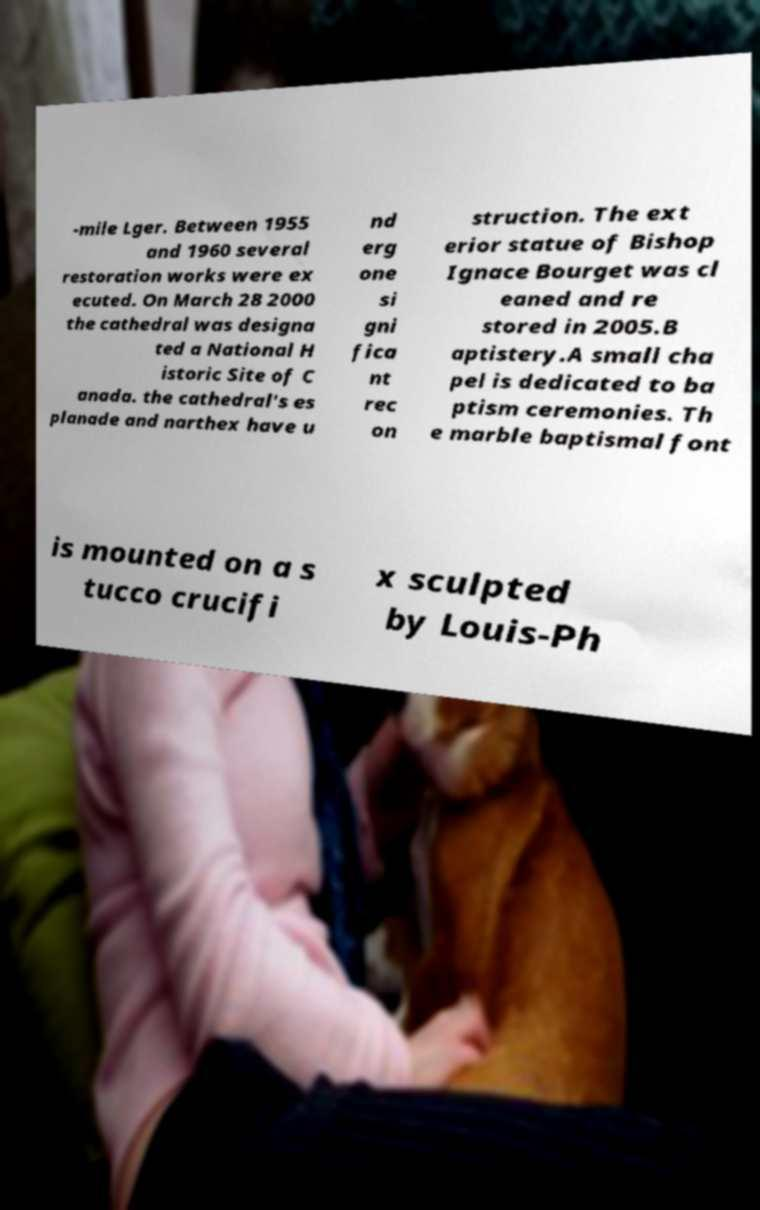I need the written content from this picture converted into text. Can you do that? -mile Lger. Between 1955 and 1960 several restoration works were ex ecuted. On March 28 2000 the cathedral was designa ted a National H istoric Site of C anada. the cathedral's es planade and narthex have u nd erg one si gni fica nt rec on struction. The ext erior statue of Bishop Ignace Bourget was cl eaned and re stored in 2005.B aptistery.A small cha pel is dedicated to ba ptism ceremonies. Th e marble baptismal font is mounted on a s tucco crucifi x sculpted by Louis-Ph 